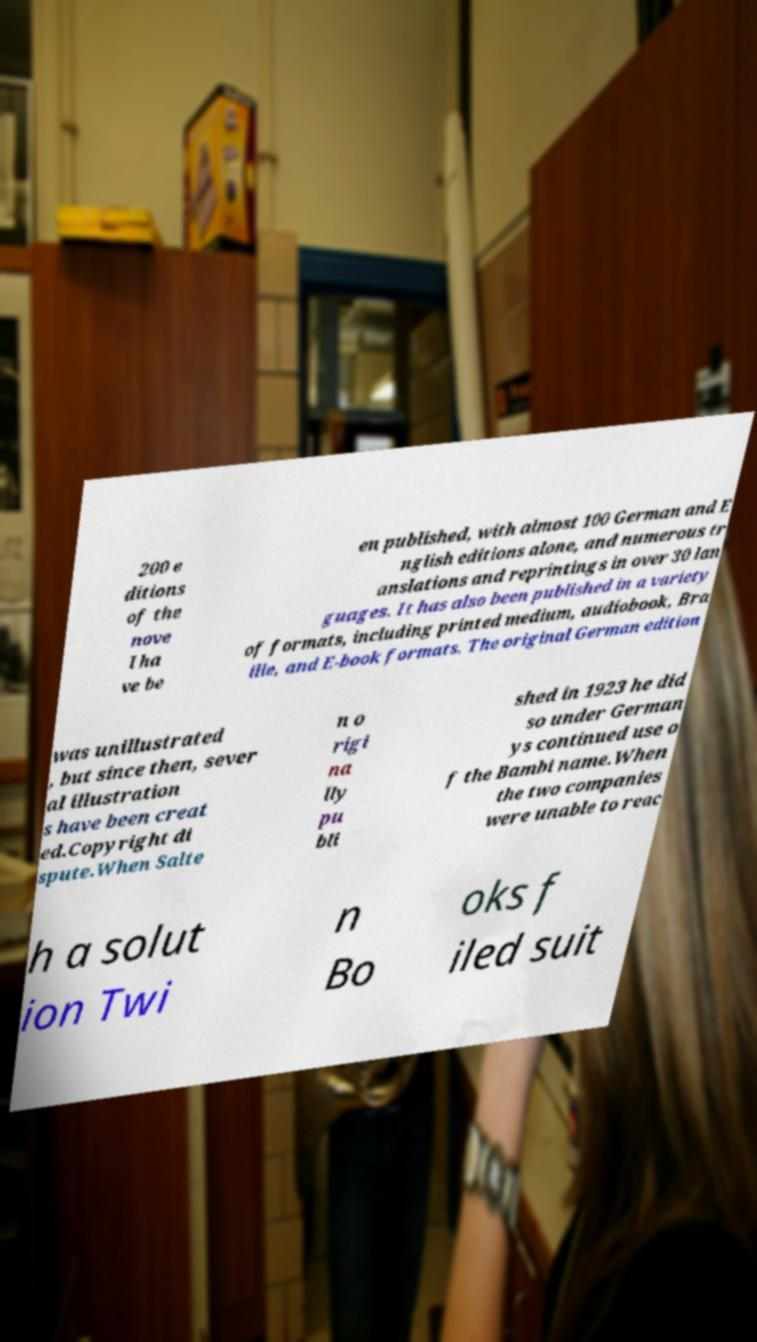For documentation purposes, I need the text within this image transcribed. Could you provide that? 200 e ditions of the nove l ha ve be en published, with almost 100 German and E nglish editions alone, and numerous tr anslations and reprintings in over 30 lan guages. It has also been published in a variety of formats, including printed medium, audiobook, Bra ille, and E-book formats. The original German edition was unillustrated , but since then, sever al illustration s have been creat ed.Copyright di spute.When Salte n o rigi na lly pu bli shed in 1923 he did so under German ys continued use o f the Bambi name.When the two companies were unable to reac h a solut ion Twi n Bo oks f iled suit 